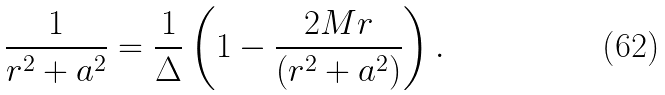Convert formula to latex. <formula><loc_0><loc_0><loc_500><loc_500>\frac { 1 } { r ^ { 2 } + a ^ { 2 } } = \frac { 1 } { \Delta } \left ( 1 - \frac { 2 M r } { ( r ^ { 2 } + a ^ { 2 } ) } \right ) .</formula> 